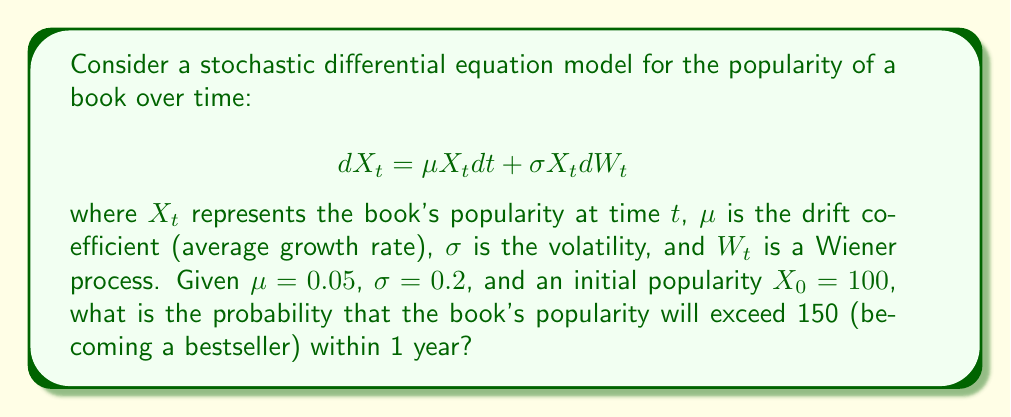Solve this math problem. To solve this problem, we'll use the properties of geometric Brownian motion, which is the solution to the given stochastic differential equation.

1. The solution to the SDE is given by:
   $$X_t = X_0 \exp\left(\left(\mu - \frac{\sigma^2}{2}\right)t + \sigma W_t\right)$$

2. We need to find $P(X_t > 150)$ at $t = 1$ year. This is equivalent to:
   $$P\left(\log\left(\frac{X_t}{X_0}\right) > \log\left(\frac{150}{100}\right)\right)$$

3. We know that $\log\left(\frac{X_t}{X_0}\right)$ follows a normal distribution with:
   Mean: $\left(\mu - \frac{\sigma^2}{2}\right)t$
   Variance: $\sigma^2 t$

4. Calculate the mean and variance:
   Mean: $\left(0.05 - \frac{0.2^2}{2}\right) \cdot 1 = 0.03$
   Variance: $0.2^2 \cdot 1 = 0.04$

5. Standardize the variable:
   $$Z = \frac{\log\left(\frac{150}{100}\right) - 0.03}{\sqrt{0.04}} = \frac{0.4055 - 0.03}{0.2} = 1.8775$$

6. The probability is then:
   $$P(X_t > 150) = 1 - \Phi(1.8775)$$
   where $\Phi$ is the standard normal cumulative distribution function.

7. Using a standard normal table or calculator:
   $$1 - \Phi(1.8775) \approx 0.0302$$

Therefore, the probability of the book becoming a bestseller (popularity exceeding 150) within 1 year is approximately 0.0302 or 3.02%.
Answer: 0.0302 